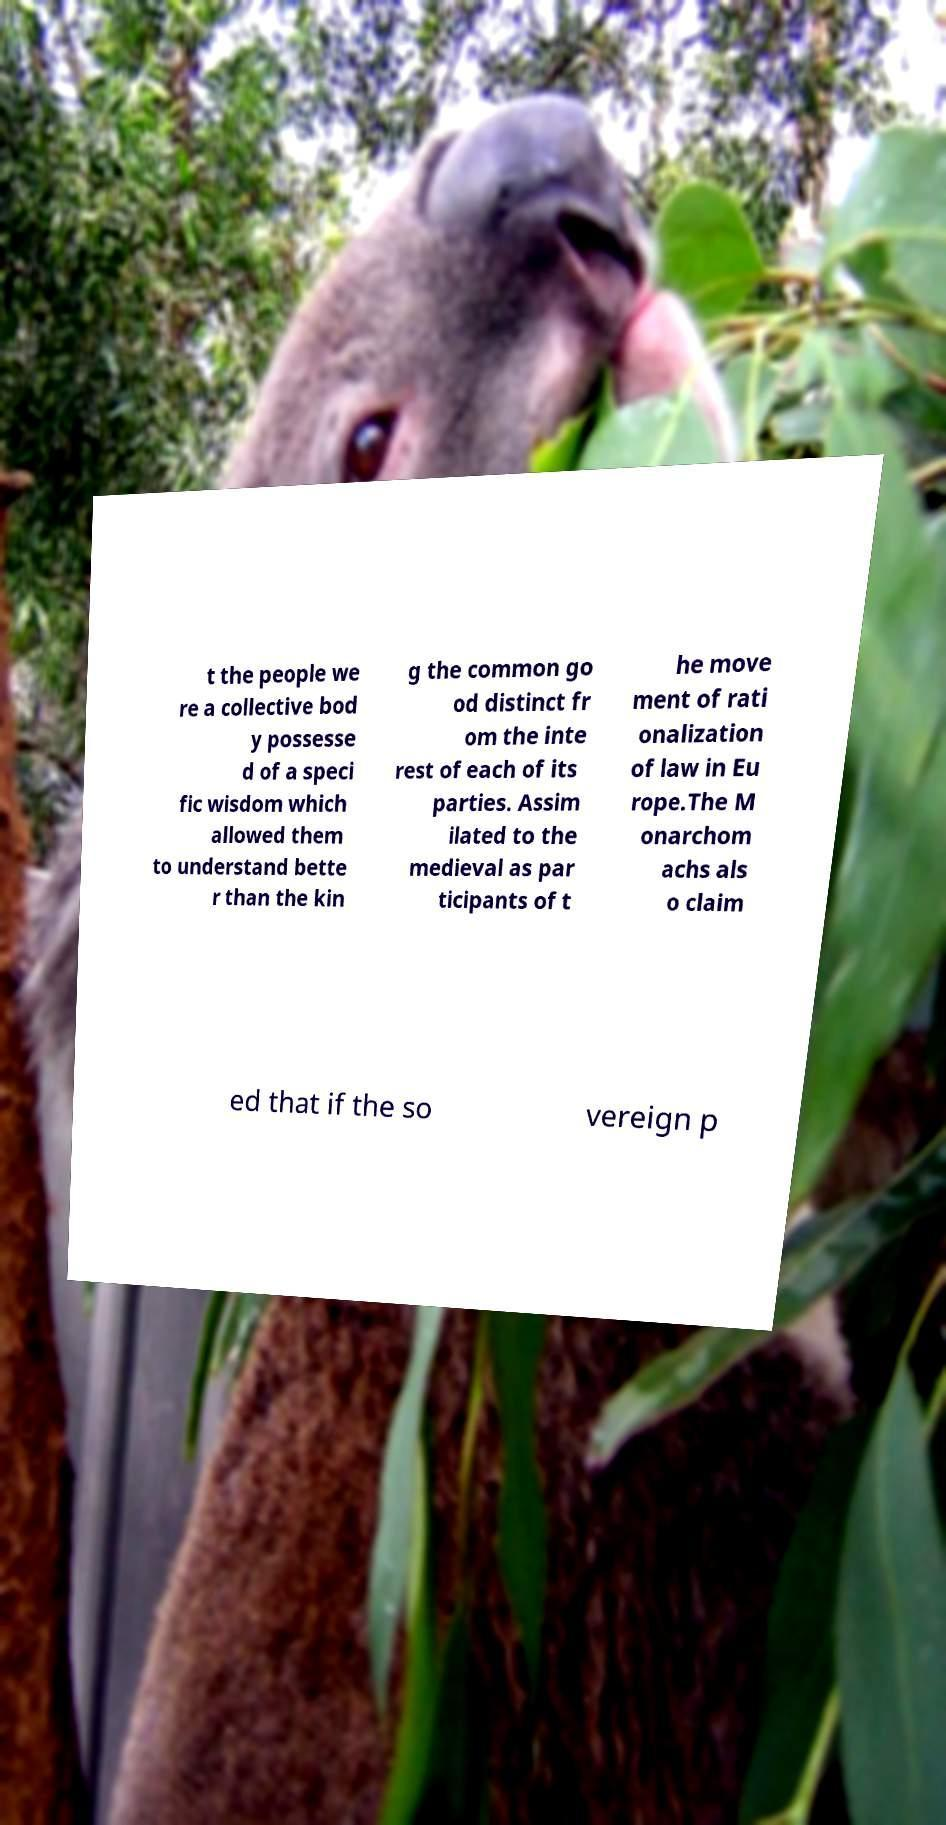I need the written content from this picture converted into text. Can you do that? t the people we re a collective bod y possesse d of a speci fic wisdom which allowed them to understand bette r than the kin g the common go od distinct fr om the inte rest of each of its parties. Assim ilated to the medieval as par ticipants of t he move ment of rati onalization of law in Eu rope.The M onarchom achs als o claim ed that if the so vereign p 